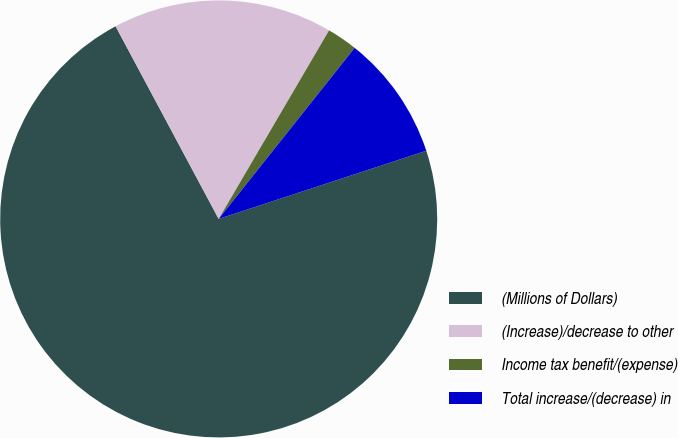<chart> <loc_0><loc_0><loc_500><loc_500><pie_chart><fcel>(Millions of Dollars)<fcel>(Increase)/decrease to other<fcel>Income tax benefit/(expense)<fcel>Total increase/(decrease) in<nl><fcel>72.23%<fcel>16.25%<fcel>2.26%<fcel>9.26%<nl></chart> 